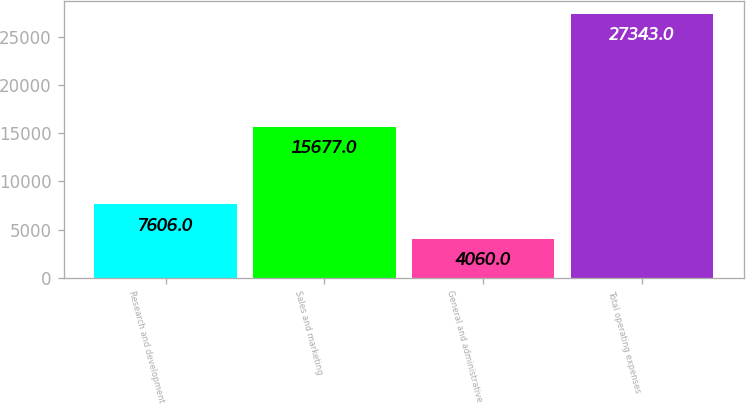Convert chart to OTSL. <chart><loc_0><loc_0><loc_500><loc_500><bar_chart><fcel>Research and development<fcel>Sales and marketing<fcel>General and administrative<fcel>Total operating expenses<nl><fcel>7606<fcel>15677<fcel>4060<fcel>27343<nl></chart> 